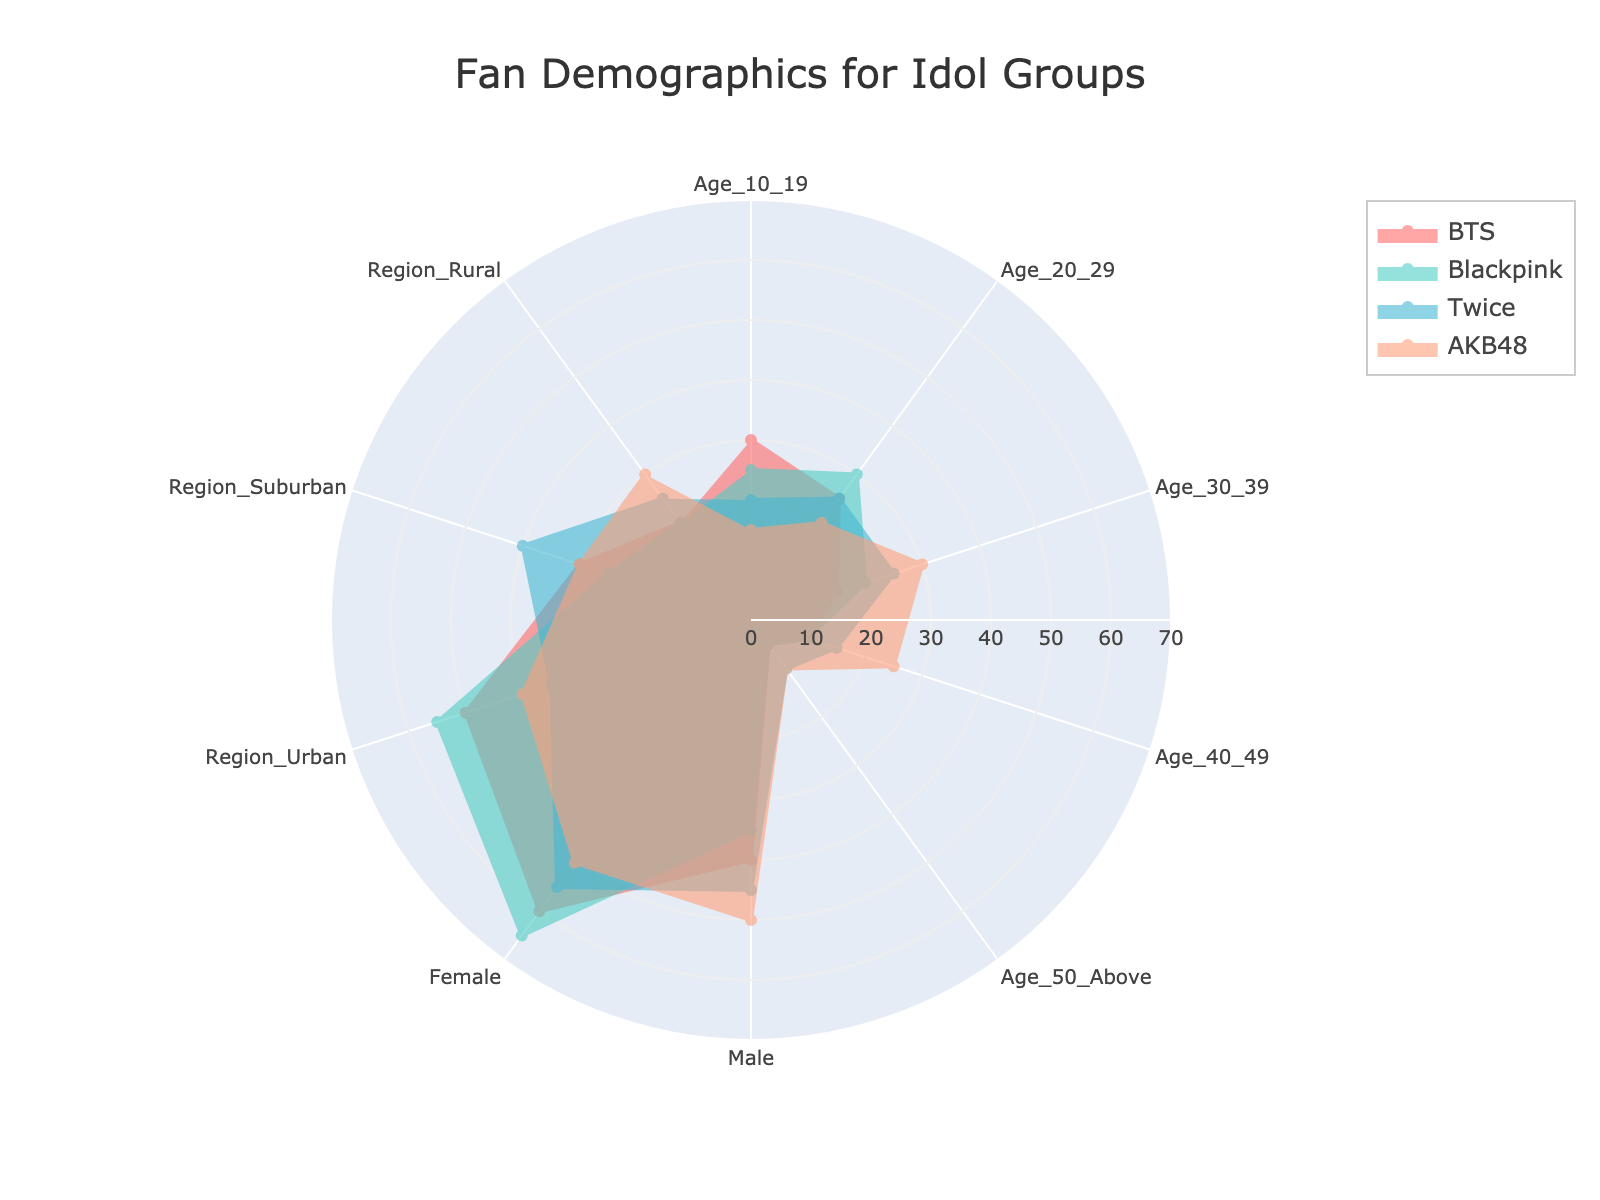What group has the largest teenage (10-19) fanbase? The segment for ages 10-19 is highest for BTS, which has a value of 30.
Answer: BTS Which group has the most urban fans? The radar chart shows BTS with the highest value in the Region_Urban segment, which is 50.
Answer: BTS Between BTS and Blackpink, which group has more female fans? By comparing the values in the Female segment, Blackpink has 65 while BTS has 60. Thus, Blackpink has more female fans.
Answer: Blackpink Which group has the smallest fanbase in the age range 50 and above? By inspecting values in the Age_50_Above segment, BTS and Blackpink both have the smallest values of 5.
Answer: BTS and Blackpink What is the average percentage of male fans for all groups? Summing up the male percentages: BTS (40) + Blackpink (35) + Twice (45) + AKB48 (50) = 170. Then, dividing by the number of groups (4) gives an average of 42.5.
Answer: 42.5 Which group has a more balanced gender distribution among fans? Comparing the Male and Female values: AKB48 has equal male and female values of 50 each, indicating the most balanced gender distribution.
Answer: AKB48 Compare the age distribution for Twice and AKB48: which group has a higher percentage of fans aged 30-39? Twice has 25% in the Age_30_39 segment while AKB48 has 30%, making AKB48 higher.
Answer: AKB48 What is the total percentage of suburban fans for all groups combined? Summing up the suburban values: BTS (30) + Blackpink (25) + Twice (40) + AKB48 (30) = 125.
Answer: 125 Which group has the least number of fans in the 40-49 age group? The Age_40_49 segment shows BTS and Blackpink both with values of 10, which are the lowest in this age group.
Answer: BTS and Blackpink How does the rural fanbase of Twice compare to that of AKB48? In the Region_Rural segment, Twice has 25% while AKB48 has 30%, indicating that AKB48 has a higher percentage of rural fans than Twice.
Answer: AKB48 